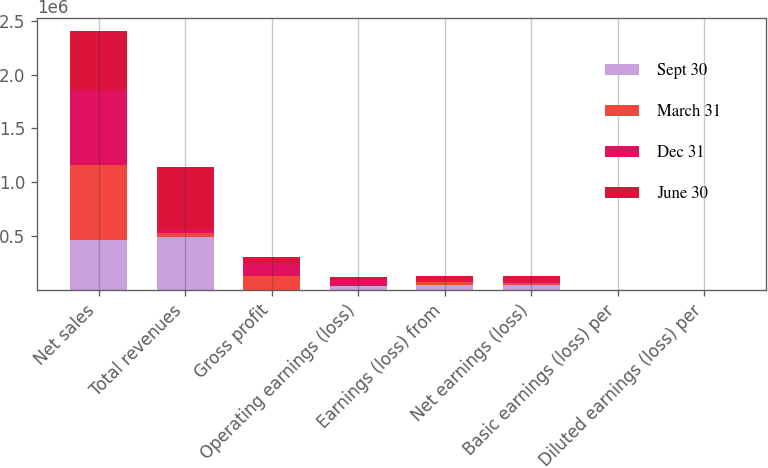Convert chart to OTSL. <chart><loc_0><loc_0><loc_500><loc_500><stacked_bar_chart><ecel><fcel>Net sales<fcel>Total revenues<fcel>Gross profit<fcel>Operating earnings (loss)<fcel>Earnings (loss) from<fcel>Net earnings (loss)<fcel>Basic earnings (loss) per<fcel>Diluted earnings (loss) per<nl><fcel>Sept 30<fcel>464534<fcel>493264<fcel>894<fcel>36770<fcel>44474<fcel>38747<fcel>0.35<fcel>0.35<nl><fcel>March 31<fcel>692758<fcel>33091<fcel>122335<fcel>1210<fcel>22515<fcel>23992<fcel>0.18<fcel>0.18<nl><fcel>Dec 31<fcel>699792<fcel>33091<fcel>126747<fcel>50432<fcel>10591<fcel>13246<fcel>0.08<fcel>0.08<nl><fcel>June 30<fcel>548832<fcel>586242<fcel>50750<fcel>29412<fcel>46145<fcel>46997<fcel>0.36<fcel>0.36<nl></chart> 